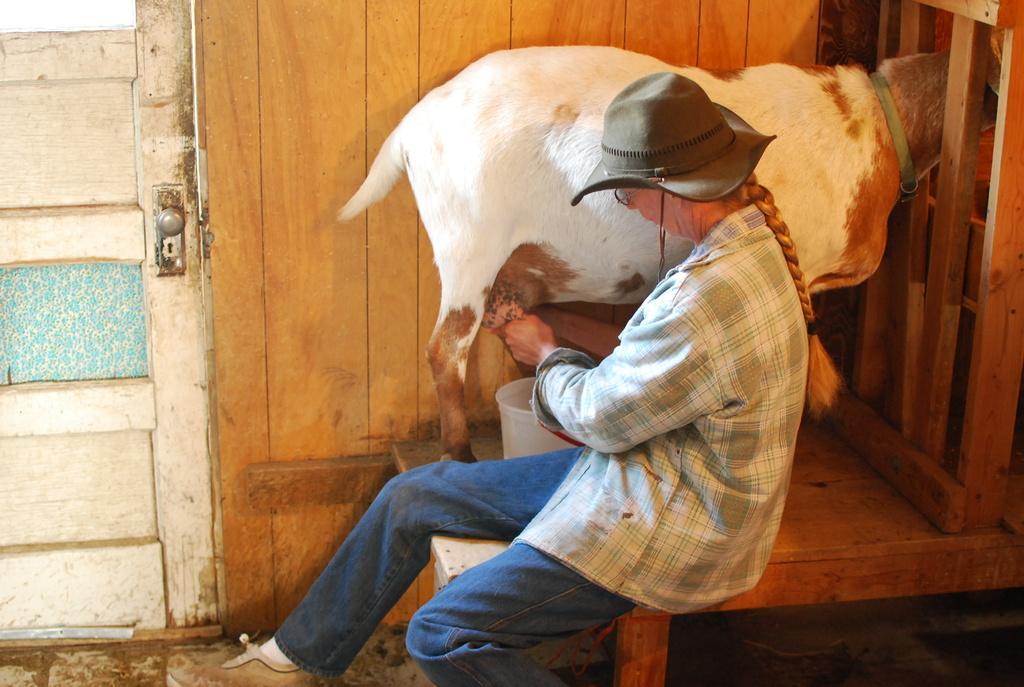Can you describe this image briefly? In this image there is a man. In front of him there is a goat. Here there is a bucket. This is the door. 